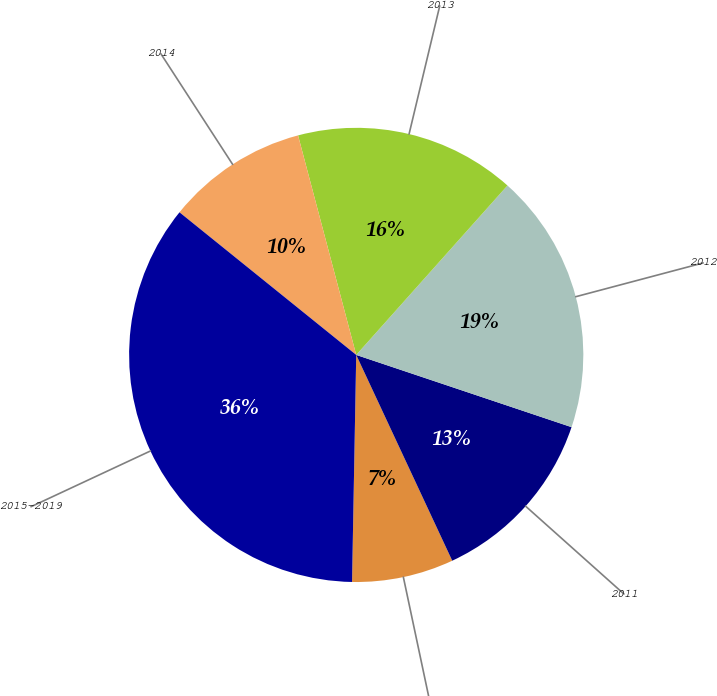Convert chart to OTSL. <chart><loc_0><loc_0><loc_500><loc_500><pie_chart><fcel>2010<fcel>2011<fcel>2012<fcel>2013<fcel>2014<fcel>2015-2019<nl><fcel>7.24%<fcel>12.9%<fcel>18.55%<fcel>15.72%<fcel>10.07%<fcel>35.51%<nl></chart> 